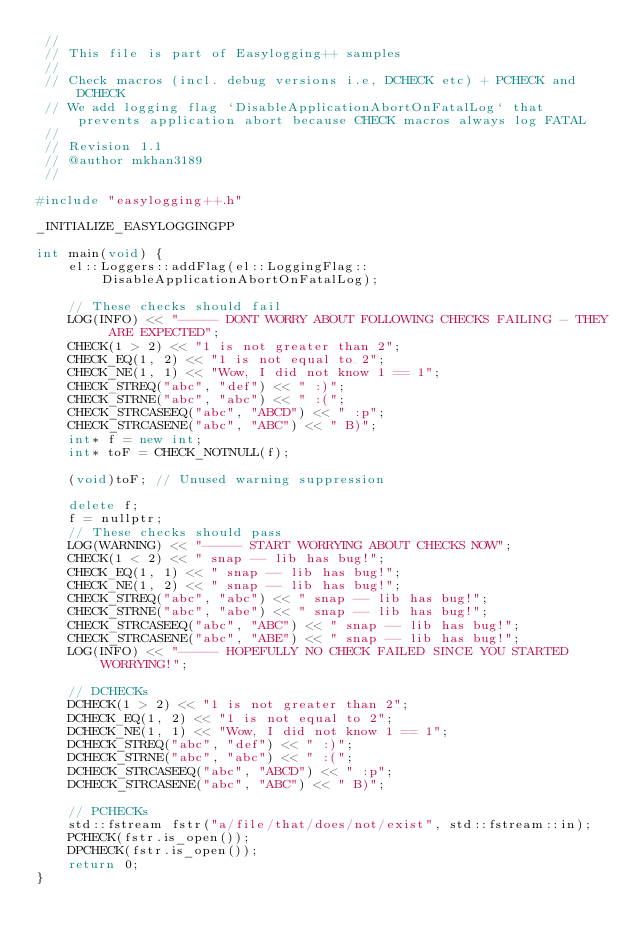<code> <loc_0><loc_0><loc_500><loc_500><_C++_> //
 // This file is part of Easylogging++ samples
 //
 // Check macros (incl. debug versions i.e, DCHECK etc) + PCHECK and DCHECK
 // We add logging flag `DisableApplicationAbortOnFatalLog` that prevents application abort because CHECK macros always log FATAL
 //
 // Revision 1.1
 // @author mkhan3189
 //

#include "easylogging++.h"

_INITIALIZE_EASYLOGGINGPP

int main(void) {
    el::Loggers::addFlag(el::LoggingFlag::DisableApplicationAbortOnFatalLog);
    
    // These checks should fail
    LOG(INFO) << "----- DONT WORRY ABOUT FOLLOWING CHECKS FAILING - THEY ARE EXPECTED";
    CHECK(1 > 2) << "1 is not greater than 2";
    CHECK_EQ(1, 2) << "1 is not equal to 2";
    CHECK_NE(1, 1) << "Wow, I did not know 1 == 1";
    CHECK_STREQ("abc", "def") << " :)";
    CHECK_STRNE("abc", "abc") << " :(";
    CHECK_STRCASEEQ("abc", "ABCD") << " :p";
    CHECK_STRCASENE("abc", "ABC") << " B)";
    int* f = new int;
    int* toF = CHECK_NOTNULL(f);

    (void)toF; // Unused warning suppression

    delete f;
    f = nullptr;
    // These checks should pass 
    LOG(WARNING) << "----- START WORRYING ABOUT CHECKS NOW";
    CHECK(1 < 2) << " snap -- lib has bug!";
    CHECK_EQ(1, 1) << " snap -- lib has bug!";
    CHECK_NE(1, 2) << " snap -- lib has bug!";
    CHECK_STREQ("abc", "abc") << " snap -- lib has bug!";
    CHECK_STRNE("abc", "abe") << " snap -- lib has bug!";
    CHECK_STRCASEEQ("abc", "ABC") << " snap -- lib has bug!";
    CHECK_STRCASENE("abc", "ABE") << " snap -- lib has bug!";
    LOG(INFO) << "----- HOPEFULLY NO CHECK FAILED SINCE YOU STARTED WORRYING!";

    // DCHECKs
    DCHECK(1 > 2) << "1 is not greater than 2";
    DCHECK_EQ(1, 2) << "1 is not equal to 2";
    DCHECK_NE(1, 1) << "Wow, I did not know 1 == 1";
    DCHECK_STREQ("abc", "def") << " :)";
    DCHECK_STRNE("abc", "abc") << " :(";
    DCHECK_STRCASEEQ("abc", "ABCD") << " :p";
    DCHECK_STRCASENE("abc", "ABC") << " B)";
    
    // PCHECKs
    std::fstream fstr("a/file/that/does/not/exist", std::fstream::in);
    PCHECK(fstr.is_open());
    DPCHECK(fstr.is_open());
    return 0;
}
</code> 